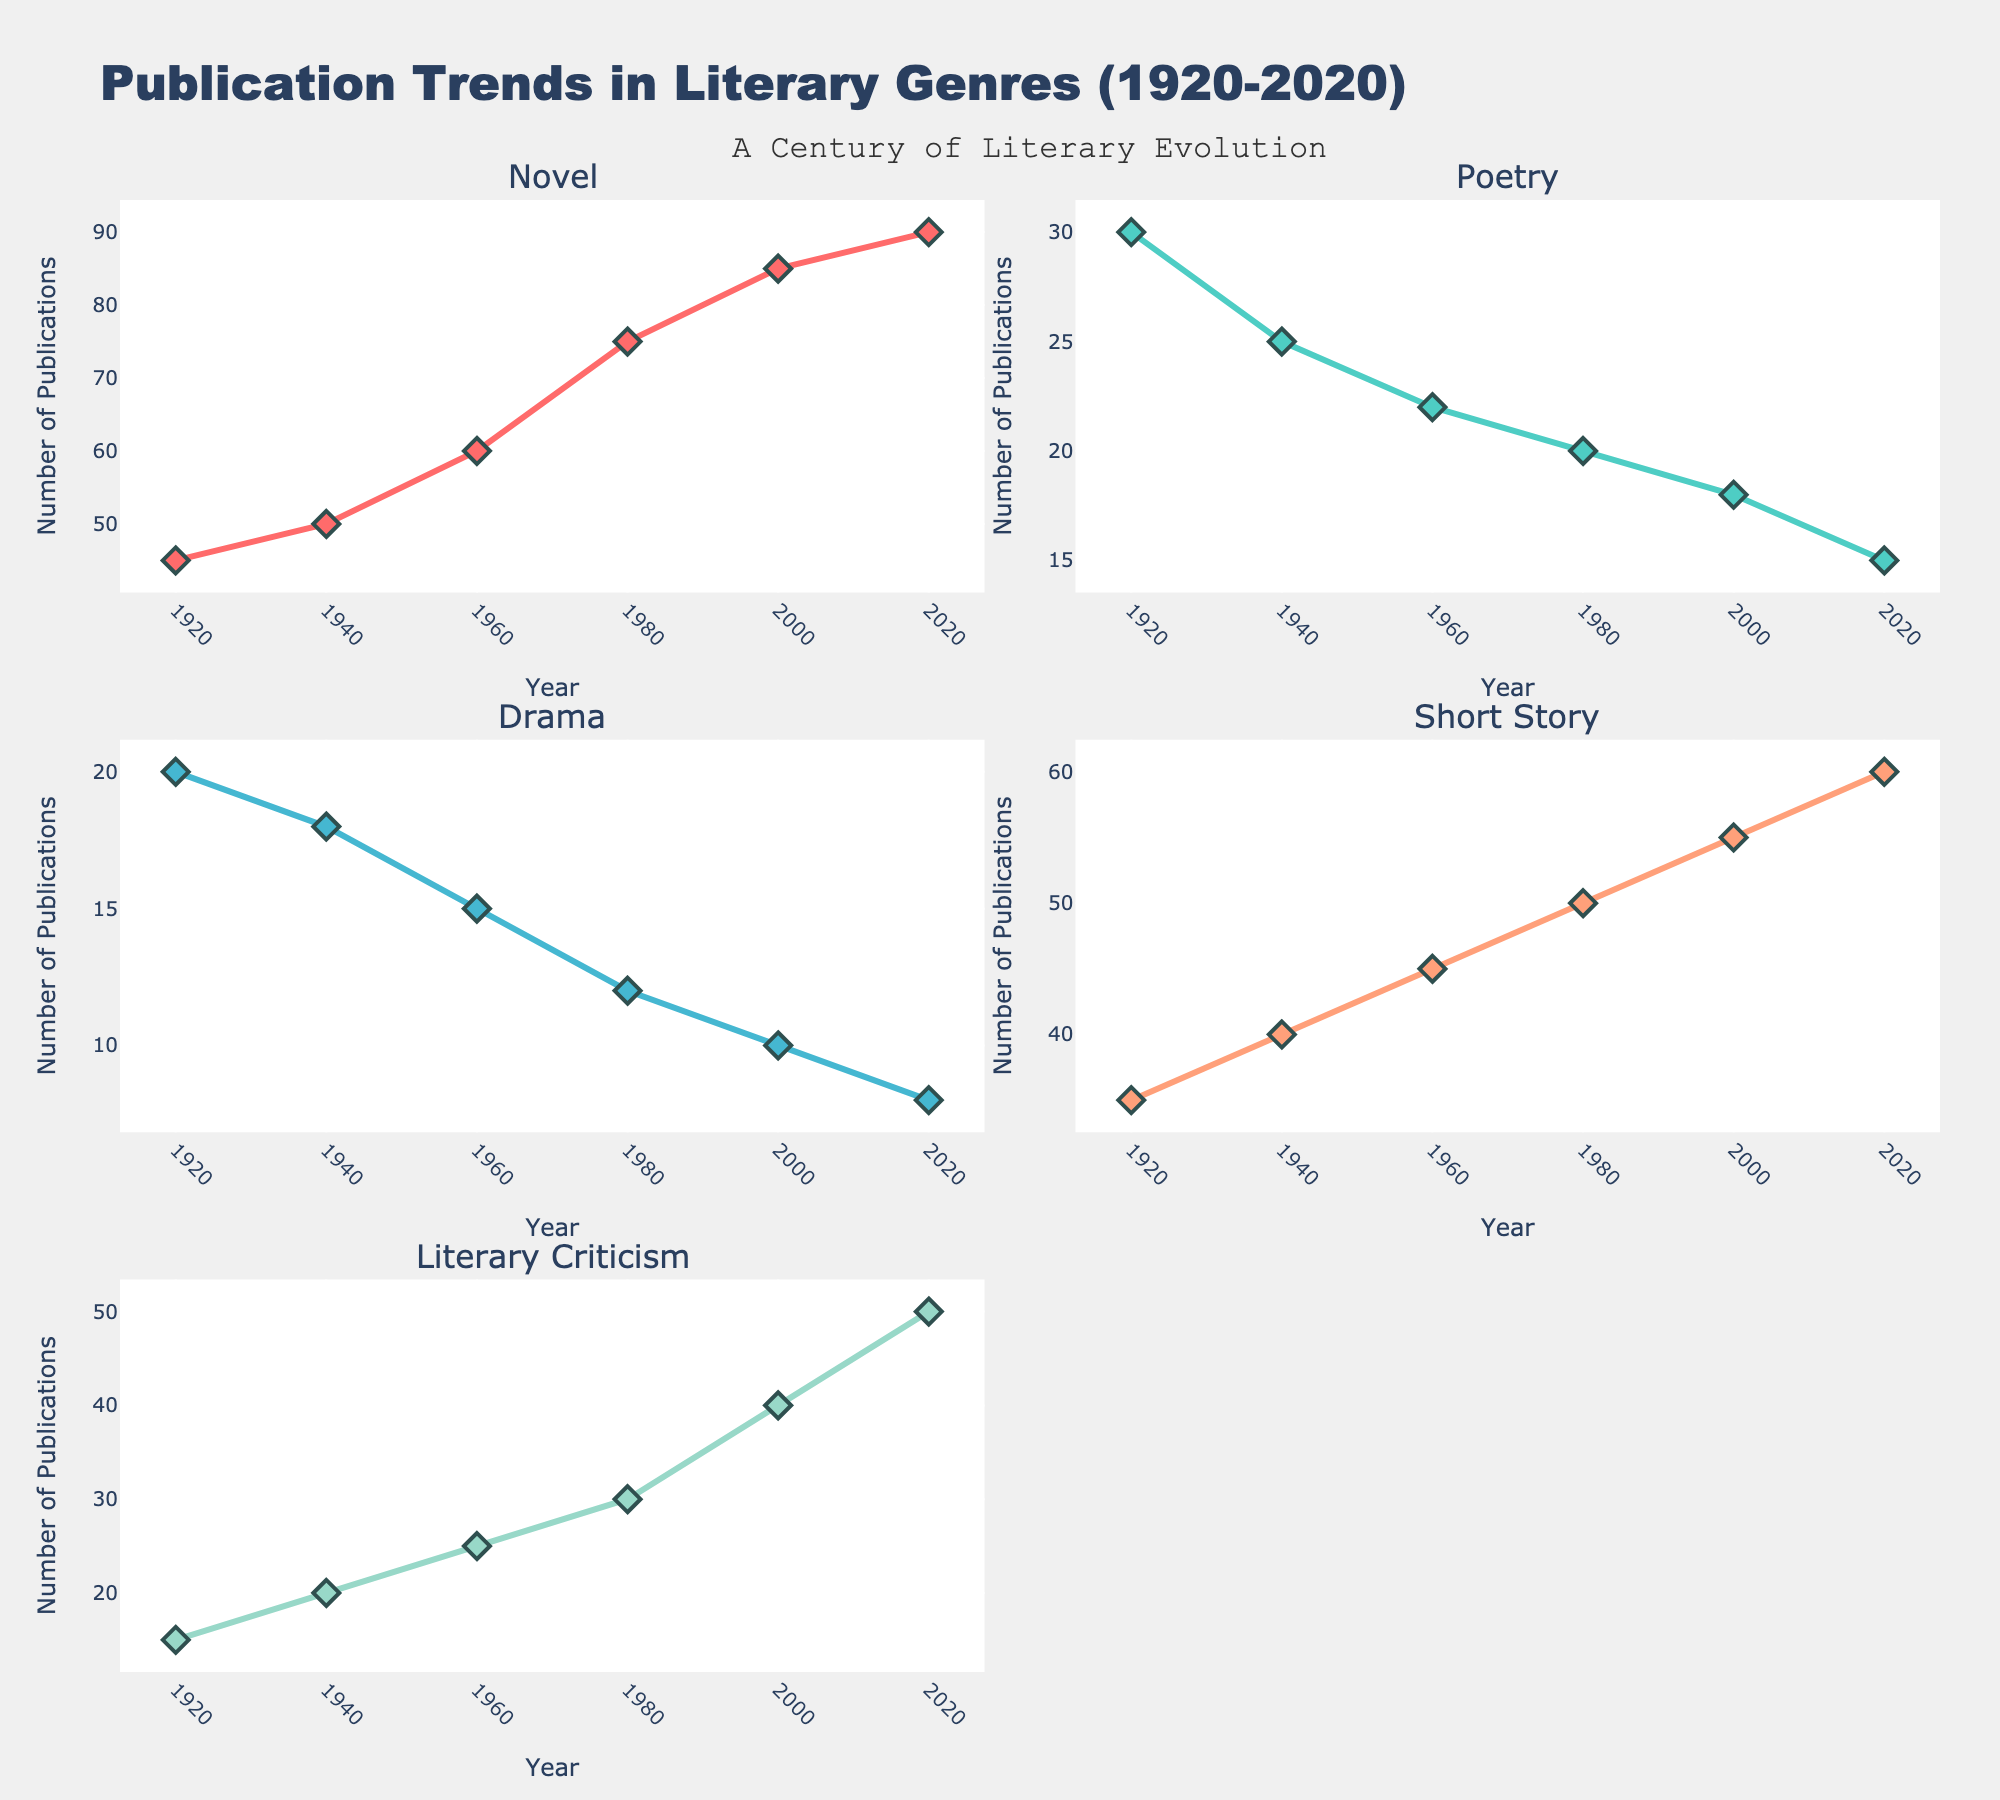What's the title of the figure? The title is displayed prominently at the top center of the figure and reads "Educational Investment and Career Earnings Potential."
Answer: Educational Investment and Career Earnings Potential Which degree has the highest mid-career salary? Looking at the "Educational Cost vs. Mid-Career Salary" subplot, the highest mid-career salary is $250,000, which corresponds to Medicine.
Answer: Medicine What is the average starting salary for degrees costing more than $100,000? Identify degrees with an average educational cost greater than $100,000, which are Computer Science, Engineering, Medicine, Law, and Chemistry. Their starting salaries are $75,000, $70,000, $120,000, $70,000, and $55,000 respectively. Sum these salaries: 75,000 + 70,000 + 120,000 + 70,000 + 55,000 = 390,000. The number of degrees is 5, so the average is 390,000 / 5 = 78,000.
Answer: $78,000 Which degrees have a starting salary less than $50,000? Look at the "Educational Cost vs. Starting Salary" subplot and identify degrees with starting salaries below $50,000. These are Education ($40,000), Psychology ($45,000), Fine Arts ($35,000), Biology ($50,000), Marketing ($50,000), and Political Science ($45,000).
Answer: Education, Psychology, Fine Arts, Political Science How does the educational cost of Law compare to that of Engineering? From the "Educational Cost vs. Starting Salary" subplot, the educational cost of Law is $150,000, and for Engineering, it's $130,000. Comparing them, Law is more expensive.
Answer: Law is more expensive than Engineering Which degrees have a mid-career salary greater than twice their starting salary? From the "Educational Cost vs. Starting Salary" and "Educational Cost vs. Mid-Career Salary" subplots, identify degrees where the mid-career salary is more than double the starting salary. These include Computer Science (120,000 > 75,000 * 2), and Engineering (115,000 nearly 70,000 * 2), Law (130,000 > 70,000 * 2).
Answer: Computer Science, Engineering, Law What is the relationship between educational cost and mid-career salary for Nursing? Locate Nursing on both subplots. Nursing has an educational cost of $80,000 and a mid-career salary of $90,000, suggesting the return on investment is slightly higher mid-career than at the start.
Answer: Mid-career salary slightly higher than educational cost Which degree has the lowest starting salary, and does it have the lowest mid-career salary as well? From the "Educational Cost vs. Starting Salary" subplot, Fine Arts has the lowest starting salary at $35,000. Cross-referencing with the "Educational Cost vs. Mid-Career Salary" subplot, Fine Arts also has the lowest mid-career salary at $60,000.
Answer: Fine Arts for both What degrees have a mid-career salary close to their educational cost? Compare the educational cost with mid-career salaries in the "Educational Cost vs. Mid-Career Salary" subplot. Computer Science (both $120,000), Business Administration (both $95,000), and Engineering ($130,000 to $115,000) are close.
Answer: Computer Science, Business Administration, Engineering 